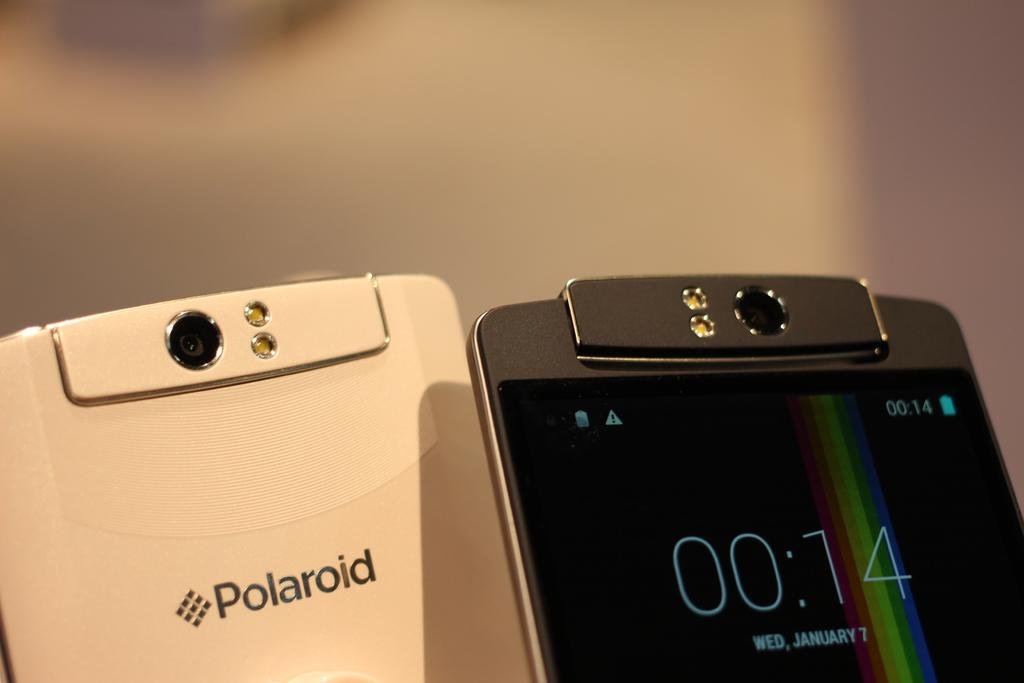<image>
Offer a succinct explanation of the picture presented. A white phone with Polaroid printed on its back next to a black phone. 